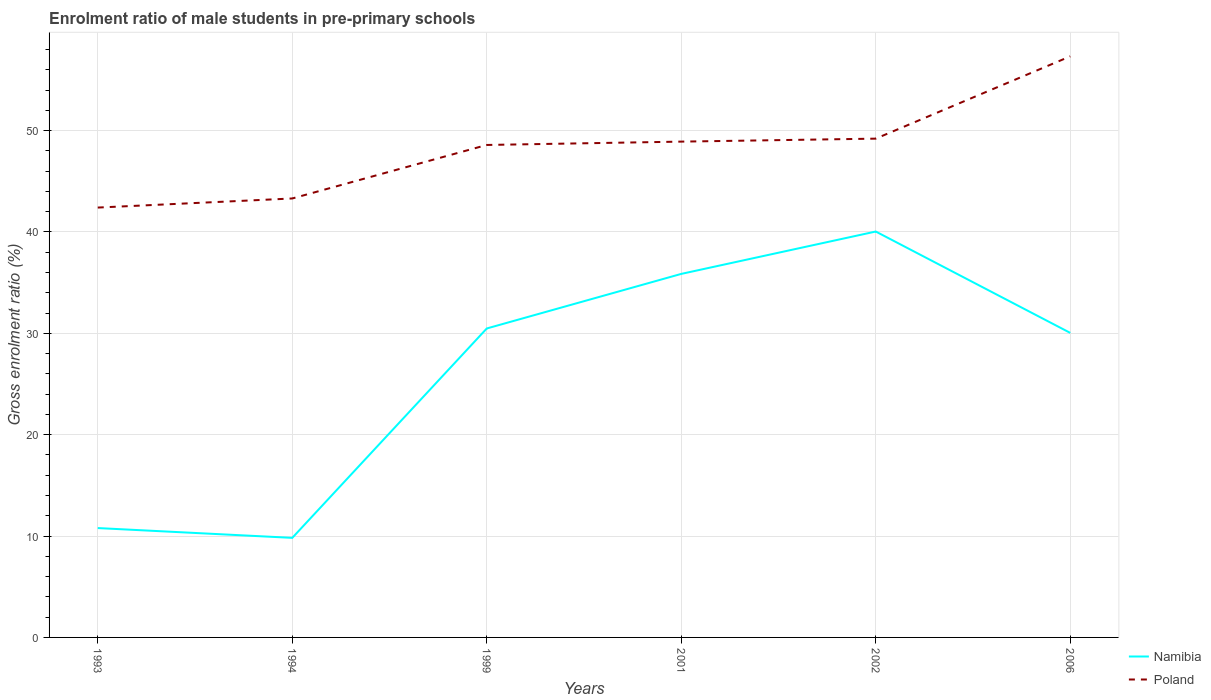Does the line corresponding to Poland intersect with the line corresponding to Namibia?
Your response must be concise. No. Is the number of lines equal to the number of legend labels?
Ensure brevity in your answer.  Yes. Across all years, what is the maximum enrolment ratio of male students in pre-primary schools in Poland?
Keep it short and to the point. 42.4. In which year was the enrolment ratio of male students in pre-primary schools in Namibia maximum?
Your response must be concise. 1994. What is the total enrolment ratio of male students in pre-primary schools in Poland in the graph?
Provide a succinct answer. -8.12. What is the difference between the highest and the second highest enrolment ratio of male students in pre-primary schools in Namibia?
Your answer should be very brief. 30.22. What is the difference between the highest and the lowest enrolment ratio of male students in pre-primary schools in Poland?
Provide a short and direct response. 4. Is the enrolment ratio of male students in pre-primary schools in Poland strictly greater than the enrolment ratio of male students in pre-primary schools in Namibia over the years?
Ensure brevity in your answer.  No. How many lines are there?
Your response must be concise. 2. How many years are there in the graph?
Make the answer very short. 6. Does the graph contain grids?
Make the answer very short. Yes. How are the legend labels stacked?
Offer a very short reply. Vertical. What is the title of the graph?
Provide a short and direct response. Enrolment ratio of male students in pre-primary schools. Does "Antigua and Barbuda" appear as one of the legend labels in the graph?
Offer a very short reply. No. What is the label or title of the X-axis?
Provide a succinct answer. Years. What is the Gross enrolment ratio (%) of Namibia in 1993?
Your answer should be very brief. 10.79. What is the Gross enrolment ratio (%) in Poland in 1993?
Keep it short and to the point. 42.4. What is the Gross enrolment ratio (%) of Namibia in 1994?
Your answer should be very brief. 9.82. What is the Gross enrolment ratio (%) of Poland in 1994?
Your response must be concise. 43.3. What is the Gross enrolment ratio (%) of Namibia in 1999?
Keep it short and to the point. 30.48. What is the Gross enrolment ratio (%) in Poland in 1999?
Give a very brief answer. 48.58. What is the Gross enrolment ratio (%) in Namibia in 2001?
Offer a terse response. 35.86. What is the Gross enrolment ratio (%) of Poland in 2001?
Your answer should be compact. 48.91. What is the Gross enrolment ratio (%) in Namibia in 2002?
Make the answer very short. 40.04. What is the Gross enrolment ratio (%) in Poland in 2002?
Ensure brevity in your answer.  49.2. What is the Gross enrolment ratio (%) in Namibia in 2006?
Your answer should be very brief. 30.04. What is the Gross enrolment ratio (%) in Poland in 2006?
Offer a very short reply. 57.32. Across all years, what is the maximum Gross enrolment ratio (%) in Namibia?
Give a very brief answer. 40.04. Across all years, what is the maximum Gross enrolment ratio (%) of Poland?
Keep it short and to the point. 57.32. Across all years, what is the minimum Gross enrolment ratio (%) in Namibia?
Provide a short and direct response. 9.82. Across all years, what is the minimum Gross enrolment ratio (%) in Poland?
Your answer should be compact. 42.4. What is the total Gross enrolment ratio (%) in Namibia in the graph?
Your answer should be compact. 157.03. What is the total Gross enrolment ratio (%) of Poland in the graph?
Give a very brief answer. 289.72. What is the difference between the Gross enrolment ratio (%) in Namibia in 1993 and that in 1994?
Ensure brevity in your answer.  0.97. What is the difference between the Gross enrolment ratio (%) of Poland in 1993 and that in 1994?
Provide a short and direct response. -0.9. What is the difference between the Gross enrolment ratio (%) in Namibia in 1993 and that in 1999?
Provide a short and direct response. -19.69. What is the difference between the Gross enrolment ratio (%) in Poland in 1993 and that in 1999?
Your response must be concise. -6.18. What is the difference between the Gross enrolment ratio (%) in Namibia in 1993 and that in 2001?
Offer a very short reply. -25.07. What is the difference between the Gross enrolment ratio (%) in Poland in 1993 and that in 2001?
Ensure brevity in your answer.  -6.51. What is the difference between the Gross enrolment ratio (%) of Namibia in 1993 and that in 2002?
Ensure brevity in your answer.  -29.25. What is the difference between the Gross enrolment ratio (%) in Poland in 1993 and that in 2002?
Offer a terse response. -6.8. What is the difference between the Gross enrolment ratio (%) in Namibia in 1993 and that in 2006?
Offer a very short reply. -19.25. What is the difference between the Gross enrolment ratio (%) of Poland in 1993 and that in 2006?
Provide a short and direct response. -14.92. What is the difference between the Gross enrolment ratio (%) of Namibia in 1994 and that in 1999?
Make the answer very short. -20.66. What is the difference between the Gross enrolment ratio (%) in Poland in 1994 and that in 1999?
Provide a succinct answer. -5.28. What is the difference between the Gross enrolment ratio (%) in Namibia in 1994 and that in 2001?
Offer a very short reply. -26.04. What is the difference between the Gross enrolment ratio (%) of Poland in 1994 and that in 2001?
Offer a very short reply. -5.61. What is the difference between the Gross enrolment ratio (%) in Namibia in 1994 and that in 2002?
Ensure brevity in your answer.  -30.22. What is the difference between the Gross enrolment ratio (%) of Poland in 1994 and that in 2002?
Your response must be concise. -5.9. What is the difference between the Gross enrolment ratio (%) of Namibia in 1994 and that in 2006?
Offer a terse response. -20.22. What is the difference between the Gross enrolment ratio (%) of Poland in 1994 and that in 2006?
Provide a succinct answer. -14.02. What is the difference between the Gross enrolment ratio (%) of Namibia in 1999 and that in 2001?
Your answer should be very brief. -5.38. What is the difference between the Gross enrolment ratio (%) of Poland in 1999 and that in 2001?
Keep it short and to the point. -0.33. What is the difference between the Gross enrolment ratio (%) of Namibia in 1999 and that in 2002?
Your response must be concise. -9.56. What is the difference between the Gross enrolment ratio (%) in Poland in 1999 and that in 2002?
Your answer should be very brief. -0.62. What is the difference between the Gross enrolment ratio (%) in Namibia in 1999 and that in 2006?
Give a very brief answer. 0.44. What is the difference between the Gross enrolment ratio (%) of Poland in 1999 and that in 2006?
Provide a short and direct response. -8.74. What is the difference between the Gross enrolment ratio (%) in Namibia in 2001 and that in 2002?
Offer a terse response. -4.18. What is the difference between the Gross enrolment ratio (%) of Poland in 2001 and that in 2002?
Make the answer very short. -0.29. What is the difference between the Gross enrolment ratio (%) in Namibia in 2001 and that in 2006?
Your answer should be very brief. 5.82. What is the difference between the Gross enrolment ratio (%) in Poland in 2001 and that in 2006?
Provide a short and direct response. -8.41. What is the difference between the Gross enrolment ratio (%) in Namibia in 2002 and that in 2006?
Ensure brevity in your answer.  10. What is the difference between the Gross enrolment ratio (%) in Poland in 2002 and that in 2006?
Your answer should be very brief. -8.12. What is the difference between the Gross enrolment ratio (%) of Namibia in 1993 and the Gross enrolment ratio (%) of Poland in 1994?
Offer a terse response. -32.51. What is the difference between the Gross enrolment ratio (%) in Namibia in 1993 and the Gross enrolment ratio (%) in Poland in 1999?
Make the answer very short. -37.79. What is the difference between the Gross enrolment ratio (%) of Namibia in 1993 and the Gross enrolment ratio (%) of Poland in 2001?
Your answer should be very brief. -38.12. What is the difference between the Gross enrolment ratio (%) in Namibia in 1993 and the Gross enrolment ratio (%) in Poland in 2002?
Your response must be concise. -38.42. What is the difference between the Gross enrolment ratio (%) in Namibia in 1993 and the Gross enrolment ratio (%) in Poland in 2006?
Your answer should be compact. -46.54. What is the difference between the Gross enrolment ratio (%) of Namibia in 1994 and the Gross enrolment ratio (%) of Poland in 1999?
Your answer should be very brief. -38.76. What is the difference between the Gross enrolment ratio (%) in Namibia in 1994 and the Gross enrolment ratio (%) in Poland in 2001?
Your response must be concise. -39.09. What is the difference between the Gross enrolment ratio (%) in Namibia in 1994 and the Gross enrolment ratio (%) in Poland in 2002?
Your response must be concise. -39.38. What is the difference between the Gross enrolment ratio (%) in Namibia in 1994 and the Gross enrolment ratio (%) in Poland in 2006?
Provide a short and direct response. -47.5. What is the difference between the Gross enrolment ratio (%) in Namibia in 1999 and the Gross enrolment ratio (%) in Poland in 2001?
Your answer should be very brief. -18.43. What is the difference between the Gross enrolment ratio (%) of Namibia in 1999 and the Gross enrolment ratio (%) of Poland in 2002?
Ensure brevity in your answer.  -18.73. What is the difference between the Gross enrolment ratio (%) of Namibia in 1999 and the Gross enrolment ratio (%) of Poland in 2006?
Offer a very short reply. -26.85. What is the difference between the Gross enrolment ratio (%) of Namibia in 2001 and the Gross enrolment ratio (%) of Poland in 2002?
Ensure brevity in your answer.  -13.34. What is the difference between the Gross enrolment ratio (%) of Namibia in 2001 and the Gross enrolment ratio (%) of Poland in 2006?
Make the answer very short. -21.46. What is the difference between the Gross enrolment ratio (%) of Namibia in 2002 and the Gross enrolment ratio (%) of Poland in 2006?
Give a very brief answer. -17.28. What is the average Gross enrolment ratio (%) of Namibia per year?
Give a very brief answer. 26.17. What is the average Gross enrolment ratio (%) in Poland per year?
Provide a short and direct response. 48.29. In the year 1993, what is the difference between the Gross enrolment ratio (%) in Namibia and Gross enrolment ratio (%) in Poland?
Keep it short and to the point. -31.62. In the year 1994, what is the difference between the Gross enrolment ratio (%) of Namibia and Gross enrolment ratio (%) of Poland?
Give a very brief answer. -33.48. In the year 1999, what is the difference between the Gross enrolment ratio (%) in Namibia and Gross enrolment ratio (%) in Poland?
Your response must be concise. -18.1. In the year 2001, what is the difference between the Gross enrolment ratio (%) in Namibia and Gross enrolment ratio (%) in Poland?
Offer a terse response. -13.05. In the year 2002, what is the difference between the Gross enrolment ratio (%) of Namibia and Gross enrolment ratio (%) of Poland?
Keep it short and to the point. -9.16. In the year 2006, what is the difference between the Gross enrolment ratio (%) of Namibia and Gross enrolment ratio (%) of Poland?
Offer a terse response. -27.28. What is the ratio of the Gross enrolment ratio (%) in Namibia in 1993 to that in 1994?
Your answer should be compact. 1.1. What is the ratio of the Gross enrolment ratio (%) of Poland in 1993 to that in 1994?
Your answer should be compact. 0.98. What is the ratio of the Gross enrolment ratio (%) of Namibia in 1993 to that in 1999?
Offer a terse response. 0.35. What is the ratio of the Gross enrolment ratio (%) of Poland in 1993 to that in 1999?
Make the answer very short. 0.87. What is the ratio of the Gross enrolment ratio (%) of Namibia in 1993 to that in 2001?
Your response must be concise. 0.3. What is the ratio of the Gross enrolment ratio (%) of Poland in 1993 to that in 2001?
Provide a succinct answer. 0.87. What is the ratio of the Gross enrolment ratio (%) in Namibia in 1993 to that in 2002?
Provide a succinct answer. 0.27. What is the ratio of the Gross enrolment ratio (%) in Poland in 1993 to that in 2002?
Your response must be concise. 0.86. What is the ratio of the Gross enrolment ratio (%) of Namibia in 1993 to that in 2006?
Your response must be concise. 0.36. What is the ratio of the Gross enrolment ratio (%) of Poland in 1993 to that in 2006?
Keep it short and to the point. 0.74. What is the ratio of the Gross enrolment ratio (%) of Namibia in 1994 to that in 1999?
Offer a terse response. 0.32. What is the ratio of the Gross enrolment ratio (%) of Poland in 1994 to that in 1999?
Your response must be concise. 0.89. What is the ratio of the Gross enrolment ratio (%) of Namibia in 1994 to that in 2001?
Ensure brevity in your answer.  0.27. What is the ratio of the Gross enrolment ratio (%) of Poland in 1994 to that in 2001?
Make the answer very short. 0.89. What is the ratio of the Gross enrolment ratio (%) in Namibia in 1994 to that in 2002?
Your answer should be compact. 0.25. What is the ratio of the Gross enrolment ratio (%) in Poland in 1994 to that in 2002?
Your response must be concise. 0.88. What is the ratio of the Gross enrolment ratio (%) of Namibia in 1994 to that in 2006?
Ensure brevity in your answer.  0.33. What is the ratio of the Gross enrolment ratio (%) of Poland in 1994 to that in 2006?
Keep it short and to the point. 0.76. What is the ratio of the Gross enrolment ratio (%) of Namibia in 1999 to that in 2001?
Ensure brevity in your answer.  0.85. What is the ratio of the Gross enrolment ratio (%) of Poland in 1999 to that in 2001?
Offer a very short reply. 0.99. What is the ratio of the Gross enrolment ratio (%) in Namibia in 1999 to that in 2002?
Your response must be concise. 0.76. What is the ratio of the Gross enrolment ratio (%) of Poland in 1999 to that in 2002?
Offer a very short reply. 0.99. What is the ratio of the Gross enrolment ratio (%) of Namibia in 1999 to that in 2006?
Ensure brevity in your answer.  1.01. What is the ratio of the Gross enrolment ratio (%) of Poland in 1999 to that in 2006?
Provide a succinct answer. 0.85. What is the ratio of the Gross enrolment ratio (%) in Namibia in 2001 to that in 2002?
Ensure brevity in your answer.  0.9. What is the ratio of the Gross enrolment ratio (%) of Namibia in 2001 to that in 2006?
Offer a terse response. 1.19. What is the ratio of the Gross enrolment ratio (%) of Poland in 2001 to that in 2006?
Your response must be concise. 0.85. What is the ratio of the Gross enrolment ratio (%) of Namibia in 2002 to that in 2006?
Ensure brevity in your answer.  1.33. What is the ratio of the Gross enrolment ratio (%) of Poland in 2002 to that in 2006?
Provide a short and direct response. 0.86. What is the difference between the highest and the second highest Gross enrolment ratio (%) in Namibia?
Give a very brief answer. 4.18. What is the difference between the highest and the second highest Gross enrolment ratio (%) in Poland?
Keep it short and to the point. 8.12. What is the difference between the highest and the lowest Gross enrolment ratio (%) in Namibia?
Keep it short and to the point. 30.22. What is the difference between the highest and the lowest Gross enrolment ratio (%) of Poland?
Ensure brevity in your answer.  14.92. 